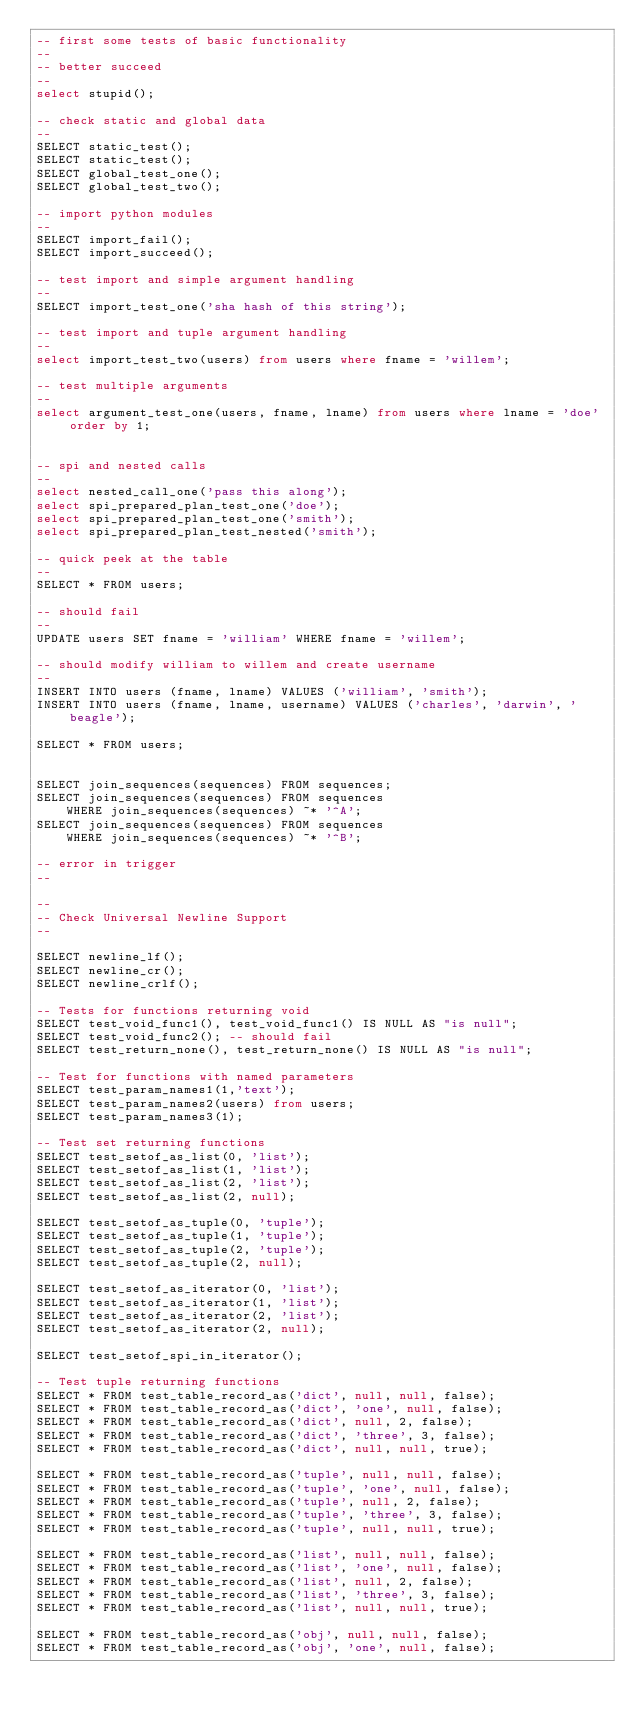<code> <loc_0><loc_0><loc_500><loc_500><_SQL_>-- first some tests of basic functionality
--
-- better succeed
--
select stupid();

-- check static and global data
--
SELECT static_test();
SELECT static_test();
SELECT global_test_one();
SELECT global_test_two();

-- import python modules
--
SELECT import_fail();
SELECT import_succeed();

-- test import and simple argument handling
--
SELECT import_test_one('sha hash of this string');

-- test import and tuple argument handling
--
select import_test_two(users) from users where fname = 'willem';

-- test multiple arguments
--
select argument_test_one(users, fname, lname) from users where lname = 'doe' order by 1;


-- spi and nested calls
--
select nested_call_one('pass this along');
select spi_prepared_plan_test_one('doe');
select spi_prepared_plan_test_one('smith');
select spi_prepared_plan_test_nested('smith');

-- quick peek at the table
--
SELECT * FROM users;

-- should fail
--
UPDATE users SET fname = 'william' WHERE fname = 'willem';

-- should modify william to willem and create username
--
INSERT INTO users (fname, lname) VALUES ('william', 'smith');
INSERT INTO users (fname, lname, username) VALUES ('charles', 'darwin', 'beagle');

SELECT * FROM users;


SELECT join_sequences(sequences) FROM sequences;
SELECT join_sequences(sequences) FROM sequences
	WHERE join_sequences(sequences) ~* '^A';
SELECT join_sequences(sequences) FROM sequences
	WHERE join_sequences(sequences) ~* '^B';

-- error in trigger
--

--
-- Check Universal Newline Support
--

SELECT newline_lf();
SELECT newline_cr();
SELECT newline_crlf();

-- Tests for functions returning void
SELECT test_void_func1(), test_void_func1() IS NULL AS "is null";
SELECT test_void_func2(); -- should fail
SELECT test_return_none(), test_return_none() IS NULL AS "is null";

-- Test for functions with named parameters
SELECT test_param_names1(1,'text');
SELECT test_param_names2(users) from users;
SELECT test_param_names3(1);

-- Test set returning functions
SELECT test_setof_as_list(0, 'list');
SELECT test_setof_as_list(1, 'list');
SELECT test_setof_as_list(2, 'list');
SELECT test_setof_as_list(2, null);

SELECT test_setof_as_tuple(0, 'tuple');
SELECT test_setof_as_tuple(1, 'tuple');
SELECT test_setof_as_tuple(2, 'tuple');
SELECT test_setof_as_tuple(2, null);

SELECT test_setof_as_iterator(0, 'list');
SELECT test_setof_as_iterator(1, 'list');
SELECT test_setof_as_iterator(2, 'list');
SELECT test_setof_as_iterator(2, null);

SELECT test_setof_spi_in_iterator();

-- Test tuple returning functions
SELECT * FROM test_table_record_as('dict', null, null, false);
SELECT * FROM test_table_record_as('dict', 'one', null, false);
SELECT * FROM test_table_record_as('dict', null, 2, false);
SELECT * FROM test_table_record_as('dict', 'three', 3, false);
SELECT * FROM test_table_record_as('dict', null, null, true);

SELECT * FROM test_table_record_as('tuple', null, null, false);
SELECT * FROM test_table_record_as('tuple', 'one', null, false);
SELECT * FROM test_table_record_as('tuple', null, 2, false);
SELECT * FROM test_table_record_as('tuple', 'three', 3, false);
SELECT * FROM test_table_record_as('tuple', null, null, true);

SELECT * FROM test_table_record_as('list', null, null, false);
SELECT * FROM test_table_record_as('list', 'one', null, false);
SELECT * FROM test_table_record_as('list', null, 2, false);
SELECT * FROM test_table_record_as('list', 'three', 3, false);
SELECT * FROM test_table_record_as('list', null, null, true);

SELECT * FROM test_table_record_as('obj', null, null, false);
SELECT * FROM test_table_record_as('obj', 'one', null, false);</code> 